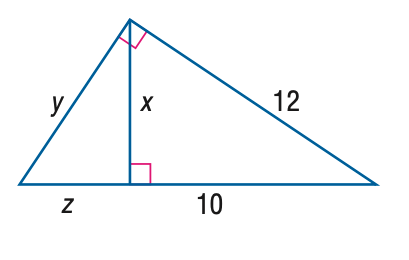Answer the mathemtical geometry problem and directly provide the correct option letter.
Question: Find z.
Choices: A: \frac { 2 } { 5 } \sqrt { 11 } B: \frac { 4 } { 5 } \sqrt { 11 } C: \frac { 22 } { 5 } D: \frac { 44 } { 5 } C 